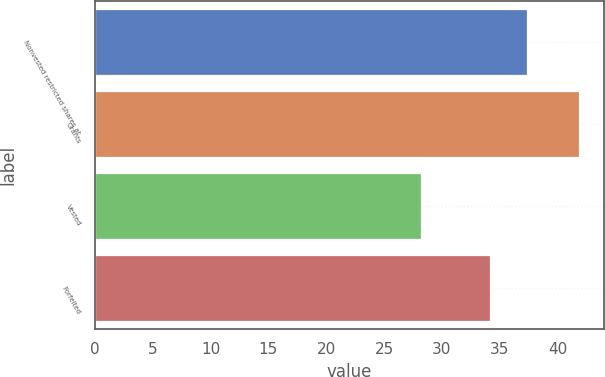Convert chart to OTSL. <chart><loc_0><loc_0><loc_500><loc_500><bar_chart><fcel>Nonvested restricted shares at<fcel>Grants<fcel>Vested<fcel>Forfeited<nl><fcel>37.38<fcel>41.89<fcel>28.23<fcel>34.12<nl></chart> 